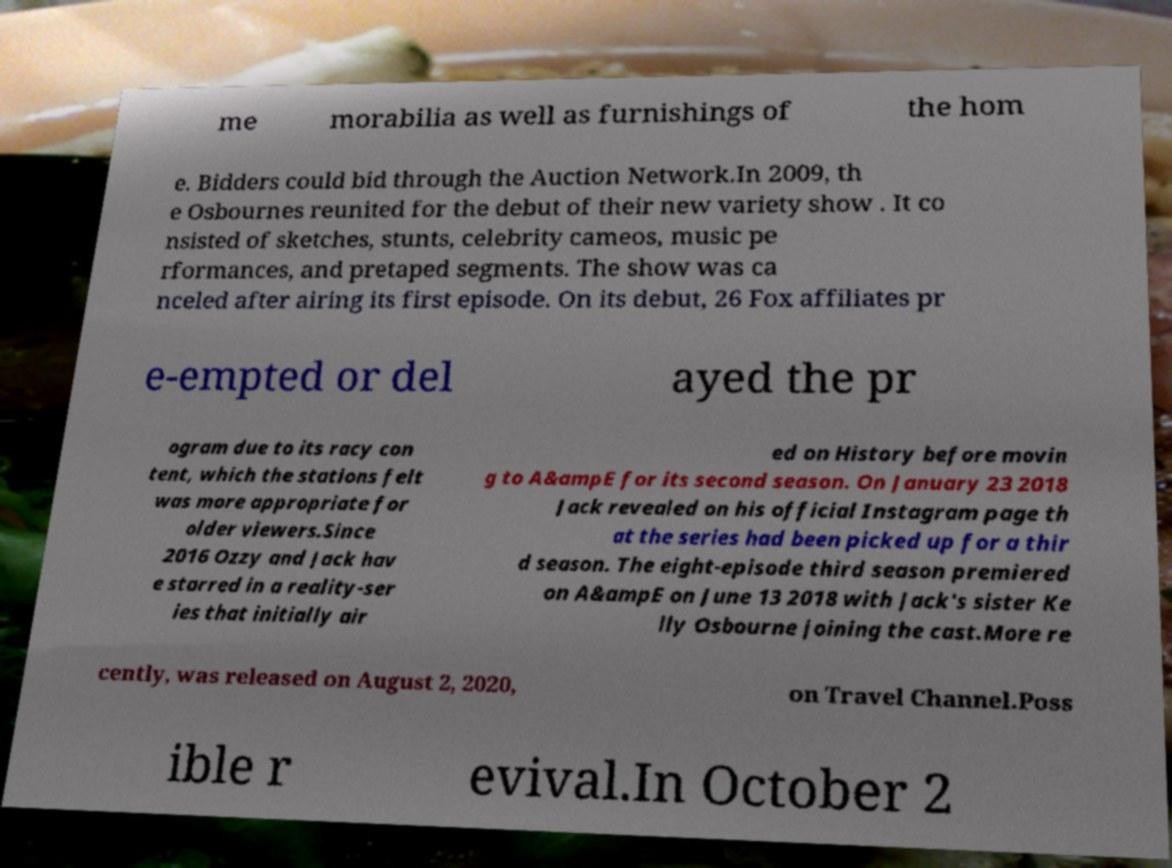Can you accurately transcribe the text from the provided image for me? me morabilia as well as furnishings of the hom e. Bidders could bid through the Auction Network.In 2009, th e Osbournes reunited for the debut of their new variety show . It co nsisted of sketches, stunts, celebrity cameos, music pe rformances, and pretaped segments. The show was ca nceled after airing its first episode. On its debut, 26 Fox affiliates pr e-empted or del ayed the pr ogram due to its racy con tent, which the stations felt was more appropriate for older viewers.Since 2016 Ozzy and Jack hav e starred in a reality-ser ies that initially air ed on History before movin g to A&ampE for its second season. On January 23 2018 Jack revealed on his official Instagram page th at the series had been picked up for a thir d season. The eight-episode third season premiered on A&ampE on June 13 2018 with Jack's sister Ke lly Osbourne joining the cast.More re cently, was released on August 2, 2020, on Travel Channel.Poss ible r evival.In October 2 